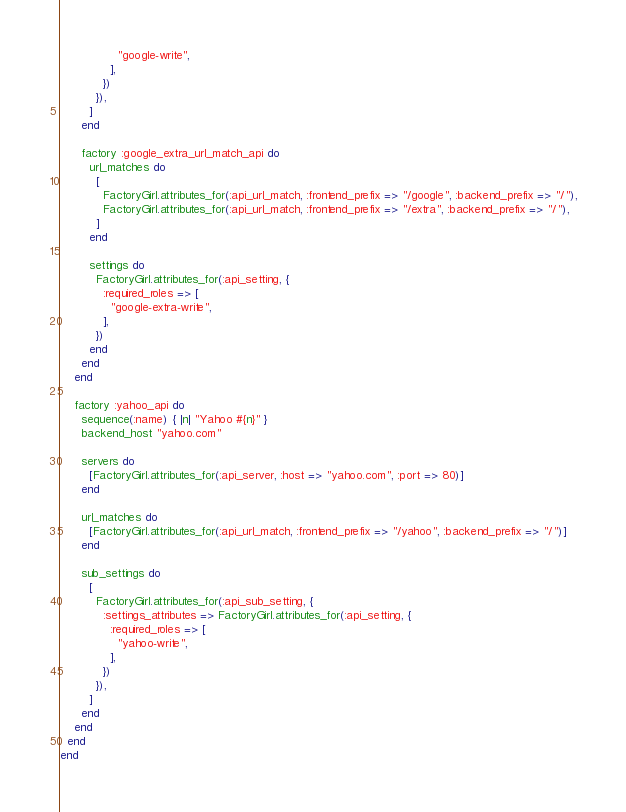Convert code to text. <code><loc_0><loc_0><loc_500><loc_500><_Ruby_>                "google-write",
              ],
            })
          }),
        ]
      end

      factory :google_extra_url_match_api do
        url_matches do
          [
            FactoryGirl.attributes_for(:api_url_match, :frontend_prefix => "/google", :backend_prefix => "/"),
            FactoryGirl.attributes_for(:api_url_match, :frontend_prefix => "/extra", :backend_prefix => "/"),
          ]
        end

        settings do
          FactoryGirl.attributes_for(:api_setting, {
            :required_roles => [
              "google-extra-write",
            ],
          })
        end
      end
    end

    factory :yahoo_api do
      sequence(:name) { |n| "Yahoo #{n}" }
      backend_host "yahoo.com"

      servers do
        [FactoryGirl.attributes_for(:api_server, :host => "yahoo.com", :port => 80)]
      end

      url_matches do
        [FactoryGirl.attributes_for(:api_url_match, :frontend_prefix => "/yahoo", :backend_prefix => "/")]
      end

      sub_settings do
        [
          FactoryGirl.attributes_for(:api_sub_setting, {
            :settings_attributes => FactoryGirl.attributes_for(:api_setting, {
              :required_roles => [
                "yahoo-write",
              ],
            })
          }),
        ]
      end
    end
  end
end
</code> 